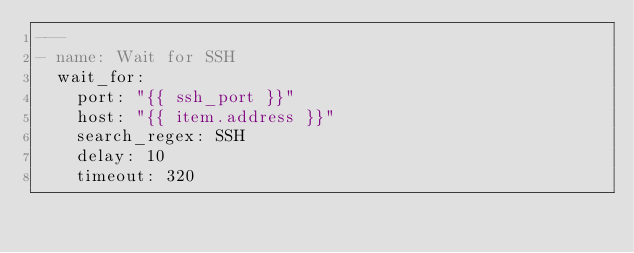<code> <loc_0><loc_0><loc_500><loc_500><_YAML_>---
- name: Wait for SSH
  wait_for:
    port: "{{ ssh_port }}"
    host: "{{ item.address }}"
    search_regex: SSH
    delay: 10
    timeout: 320</code> 